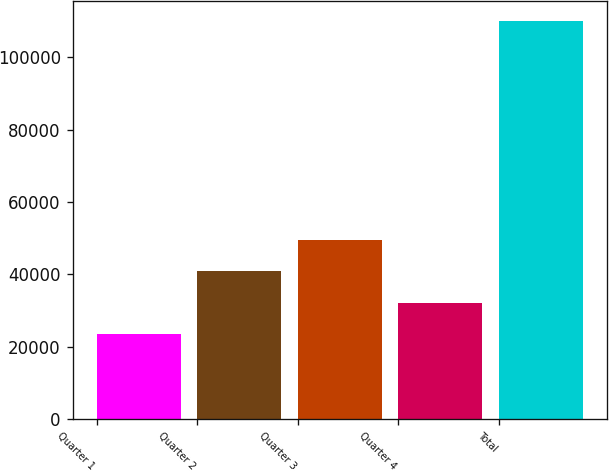Convert chart to OTSL. <chart><loc_0><loc_0><loc_500><loc_500><bar_chart><fcel>Quarter 1<fcel>Quarter 2<fcel>Quarter 3<fcel>Quarter 4<fcel>Total<nl><fcel>23468<fcel>40771.4<fcel>49423.1<fcel>32119.7<fcel>109985<nl></chart> 